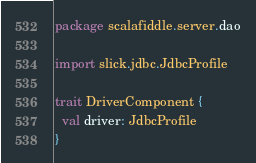Convert code to text. <code><loc_0><loc_0><loc_500><loc_500><_Scala_>package scalafiddle.server.dao

import slick.jdbc.JdbcProfile

trait DriverComponent {
  val driver: JdbcProfile
}
</code> 